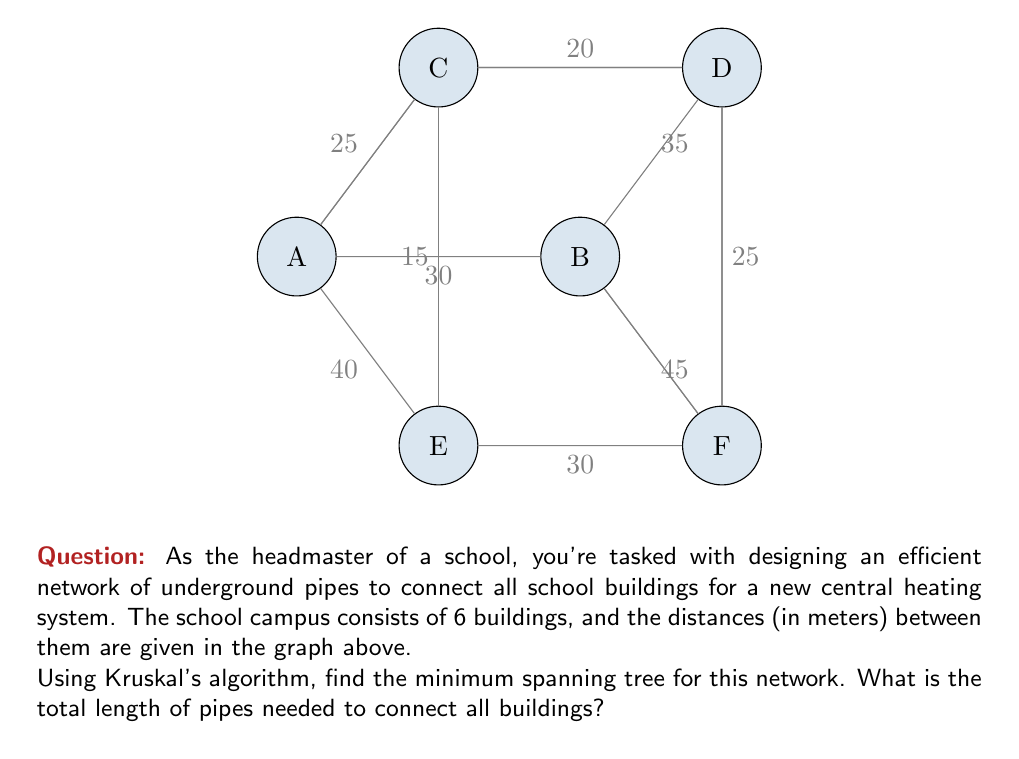Show me your answer to this math problem. To solve this problem using Kruskal's algorithm, we'll follow these steps:

1) First, list all edges in ascending order of weight:
   CE: 15, CD: 20, AC: 25, DF: 25, AB: 30, EF: 30, BD: 35, AE: 40, BF: 45

2) Start with an empty set of edges and add edges one by one, ensuring no cycles are formed:

   - Add CE (15m)
   - Add CD (20m)
   - Add AC (25m)
   - Add DF (25m)
   - Add AB (30m)

3) At this point, we have added 5 edges, which is sufficient to connect all 6 vertices without forming any cycles. This forms our minimum spanning tree.

4) Calculate the total length by summing the weights of the selected edges:

   $$ 15 + 20 + 25 + 25 + 30 = 115 $$

Therefore, the minimum spanning tree requires 115 meters of pipes to connect all buildings efficiently.
Answer: 115 meters 